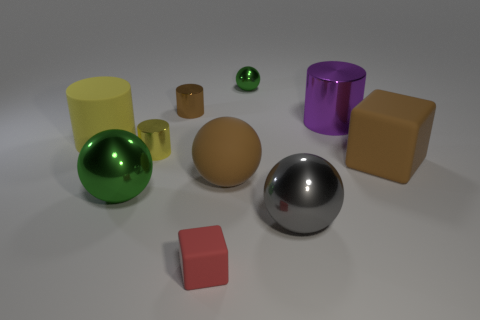How many yellow cylinders must be subtracted to get 1 yellow cylinders? 1 Subtract all brown spheres. How many spheres are left? 3 Subtract all gray balls. How many balls are left? 3 Subtract 1 balls. How many balls are left? 3 Add 5 big purple shiny objects. How many big purple shiny objects exist? 6 Subtract 0 blue cubes. How many objects are left? 10 Subtract all spheres. How many objects are left? 6 Subtract all cyan cubes. Subtract all red cylinders. How many cubes are left? 2 Subtract all gray spheres. How many brown blocks are left? 1 Subtract all big metal balls. Subtract all purple metallic cylinders. How many objects are left? 7 